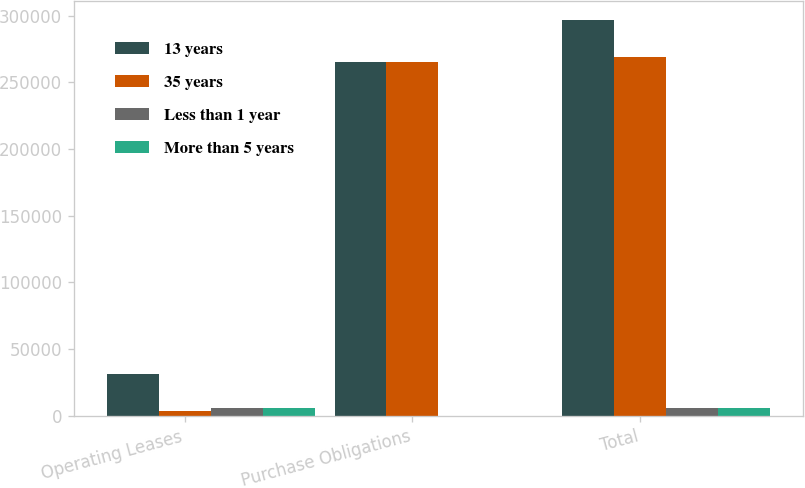Convert chart to OTSL. <chart><loc_0><loc_0><loc_500><loc_500><stacked_bar_chart><ecel><fcel>Operating Leases<fcel>Purchase Obligations<fcel>Total<nl><fcel>13 years<fcel>31145<fcel>265409<fcel>296554<nl><fcel>35 years<fcel>3357<fcel>265409<fcel>268766<nl><fcel>Less than 1 year<fcel>6271<fcel>0<fcel>6271<nl><fcel>More than 5 years<fcel>6040<fcel>0<fcel>6040<nl></chart> 